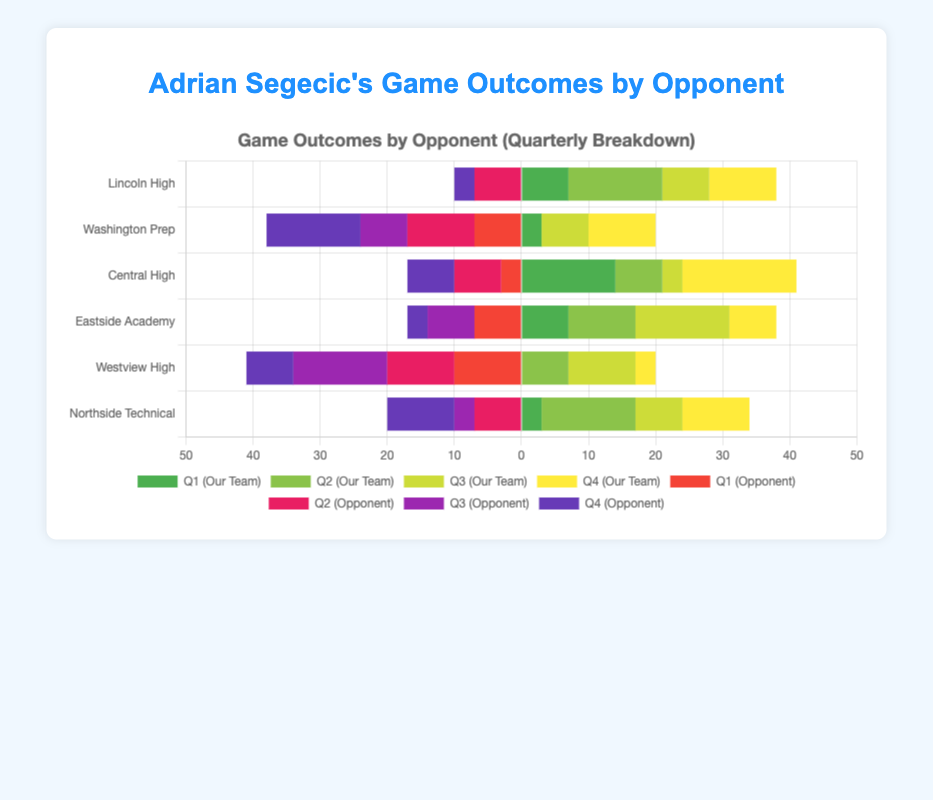Which opponent did our team score the most points against in the first quarter? Look at the bar segments corresponding to the "first quarter" for "our team" across all opponents. The tallest green bar segment is for the game against Central High, where our team scored 14 points.
Answer: Central High How many total points did our team score in the game against Lincoln High? To get the total, sum up the points scored by our team in all four quarters: 7 (Q1) + 14 (Q2) + 7 (Q3) + 10 (Q4) = 38 points.
Answer: 38 Compare our team's performance in the third quarter against Washington Prep and Westview High. Which was better? Look at the green bar segments for the "third quarter" of games against Washington Prep and Westview High. Our team scored 7 points in both games, indicated by the equal-height segments. Thus, their performance was the same.
Answer: Same What is the difference in the fourth-quarter points scored by Northside Technical compared to Lincoln High? Our team scored 10 points in the fourth quarter against Northside Technical and 10 points against Lincoln High. The difference is 10 - 10 = 0.
Answer: 0 Which opponent scored the most points against us in the second quarter? Look at the bar segments corresponding to the "second quarter" for the opposing teams across all opponents. The tallest red bar segment is for the game against Washington Prep, where they scored 10 points.
Answer: Washington Prep How do the total points scored by both teams compare in the game against Westview High? Sum up the points for our team: 0 (Q1) + 7 (Q2) + 10 (Q3) + 3 (Q4) = 20 and for Westview High: 10 (Q1) + 10 (Q2) + 14 (Q3) + 7 (Q4) = 41. Westview High scored more points overall.
Answer: Westview High scored more What is the color of the bar segment representing the fourth-quarter points for our team? Look at the fourth-quarter bar segments corresponding to our team for any game. These segments are colored yellow.
Answer: Yellow Calculate the average points scored by our team in the first quarter across all games. Sum the first-quarter points for all games: 7 + 3 + 14 + 7 + 0 + 3 = 34 points. There are 6 games, so the average is 34 / 6 ≈ 5.67 points.
Answer: 5.67 In which game did our team score equal points in all four quarters? Check the bar segments for all four quarters across all games. All quarters have different point heights, so the team did not score equal points in any game.
Answer: None Which quarter had the highest cumulative points for our team across all games? Sum the points for our team in each quarter across all games: Q1: 34, Q2: 52, Q3: 48, Q4: 57. The fourth quarter had the highest cumulative points.
Answer: Fourth quarter 